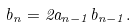Convert formula to latex. <formula><loc_0><loc_0><loc_500><loc_500>b _ { n } = 2 a _ { n - 1 } b _ { n - 1 } .</formula> 